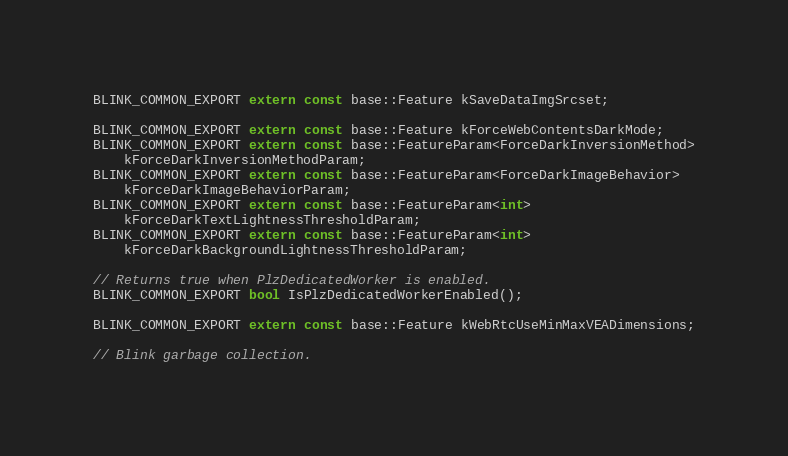Convert code to text. <code><loc_0><loc_0><loc_500><loc_500><_C_>BLINK_COMMON_EXPORT extern const base::Feature kSaveDataImgSrcset;

BLINK_COMMON_EXPORT extern const base::Feature kForceWebContentsDarkMode;
BLINK_COMMON_EXPORT extern const base::FeatureParam<ForceDarkInversionMethod>
    kForceDarkInversionMethodParam;
BLINK_COMMON_EXPORT extern const base::FeatureParam<ForceDarkImageBehavior>
    kForceDarkImageBehaviorParam;
BLINK_COMMON_EXPORT extern const base::FeatureParam<int>
    kForceDarkTextLightnessThresholdParam;
BLINK_COMMON_EXPORT extern const base::FeatureParam<int>
    kForceDarkBackgroundLightnessThresholdParam;

// Returns true when PlzDedicatedWorker is enabled.
BLINK_COMMON_EXPORT bool IsPlzDedicatedWorkerEnabled();

BLINK_COMMON_EXPORT extern const base::Feature kWebRtcUseMinMaxVEADimensions;

// Blink garbage collection.</code> 